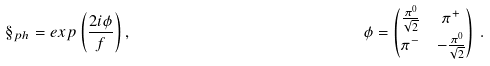Convert formula to latex. <formula><loc_0><loc_0><loc_500><loc_500>& \S _ { p h } = e x p \left ( \frac { 2 i \phi } { f } \right ) , & & \phi = \begin{pmatrix} \frac { \pi ^ { 0 } } { \sqrt { 2 } } & \pi ^ { + } \\ \pi ^ { - } & - \frac { \pi ^ { 0 } } { \sqrt { 2 } } \end{pmatrix} \, . &</formula> 